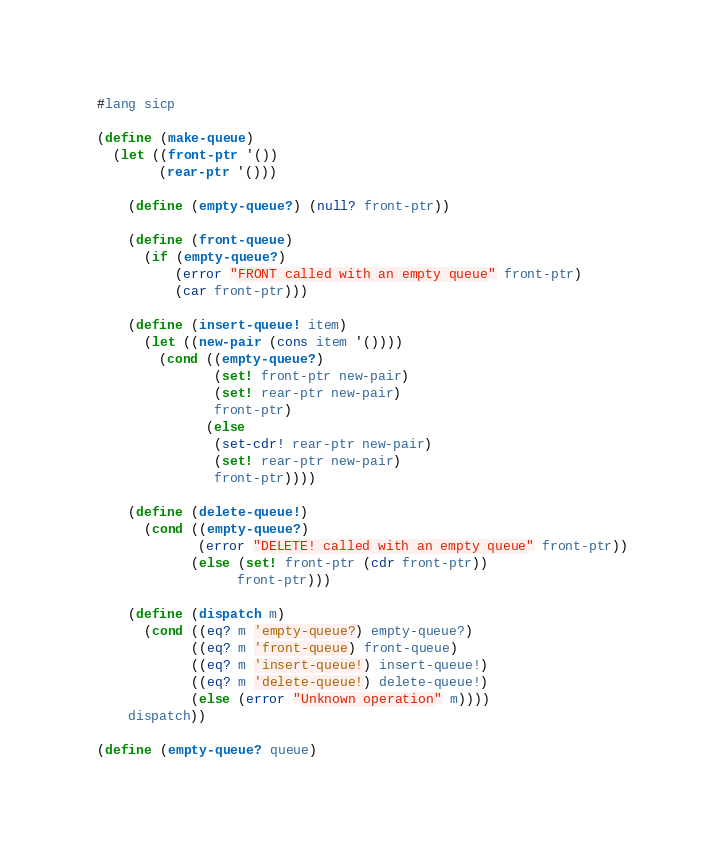Convert code to text. <code><loc_0><loc_0><loc_500><loc_500><_Scheme_>#lang sicp

(define (make-queue)
  (let ((front-ptr '())
        (rear-ptr '()))

    (define (empty-queue?) (null? front-ptr))

    (define (front-queue)
      (if (empty-queue?)
          (error "FRONT called with an empty queue" front-ptr)
          (car front-ptr)))

    (define (insert-queue! item)
      (let ((new-pair (cons item '())))
        (cond ((empty-queue?)
               (set! front-ptr new-pair)
               (set! rear-ptr new-pair)
               front-ptr)
              (else
               (set-cdr! rear-ptr new-pair)
               (set! rear-ptr new-pair)
               front-ptr))))

    (define (delete-queue!)
      (cond ((empty-queue?)
             (error "DELETE! called with an empty queue" front-ptr))
            (else (set! front-ptr (cdr front-ptr))
                  front-ptr)))

    (define (dispatch m)
      (cond ((eq? m 'empty-queue?) empty-queue?)
            ((eq? m 'front-queue) front-queue)
            ((eq? m 'insert-queue!) insert-queue!)
            ((eq? m 'delete-queue!) delete-queue!)
            (else (error "Unknown operation" m))))
    dispatch))

(define (empty-queue? queue)</code> 